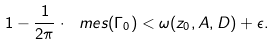<formula> <loc_0><loc_0><loc_500><loc_500>1 - \frac { 1 } { 2 \pi } \cdot \ m e s ( \Gamma _ { 0 } ) < \omega ( z _ { 0 } , A , D ) + \epsilon .</formula> 